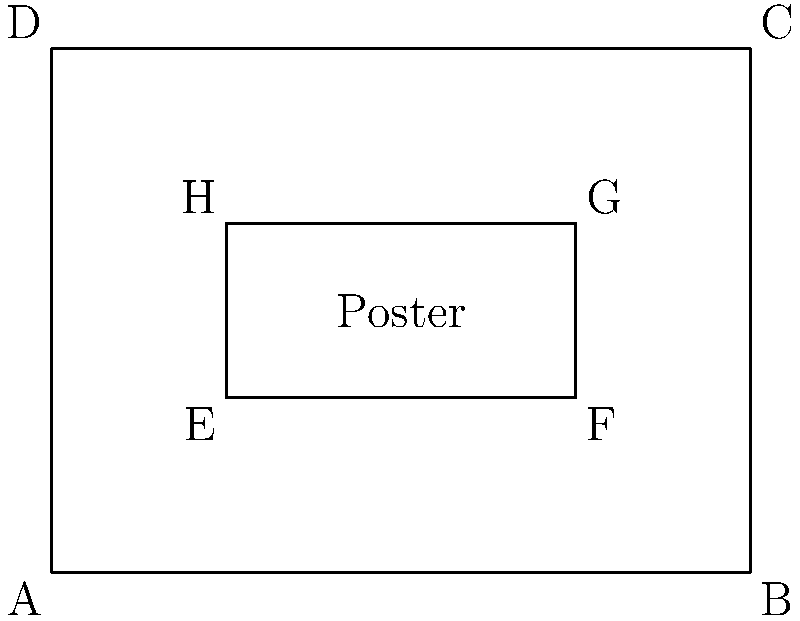For a fundraising event poster promoting girl's education, you've designed a rectangular frame ABCD with an inner rectangle EFGH representing the main content area. If EFGH is congruent to a rectangle that is 1/4 the size of ABCD, what fraction of the total poster area does the content area (EFGH) occupy? Let's approach this step-by-step:

1) First, we need to understand what congruence means in this context. If EFGH is congruent to a rectangle that is 1/4 the size of ABCD, it means that the area of EFGH is 1/4 of 1/4 (or 1/16) of the area of ABCD.

2) We can express this mathematically:
   Area of EFGH = $\frac{1}{4} \times \frac{1}{4} = \frac{1}{16}$ of the area of ABCD

3) Now, to find what fraction of the total poster area the content area occupies, we simply need to express 1/16 as a fraction:

   $\frac{1}{16} = \frac{1}{16}$

4) Therefore, the content area (EFGH) occupies 1/16 of the total poster area (ABCD).

This question relates to the persona of a village elder organizing fundraising events by incorporating elements of poster design and mathematical concepts, which could be useful in planning and explaining the layout of promotional materials for education fundraising events.
Answer: $\frac{1}{16}$ 